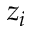Convert formula to latex. <formula><loc_0><loc_0><loc_500><loc_500>z _ { i }</formula> 